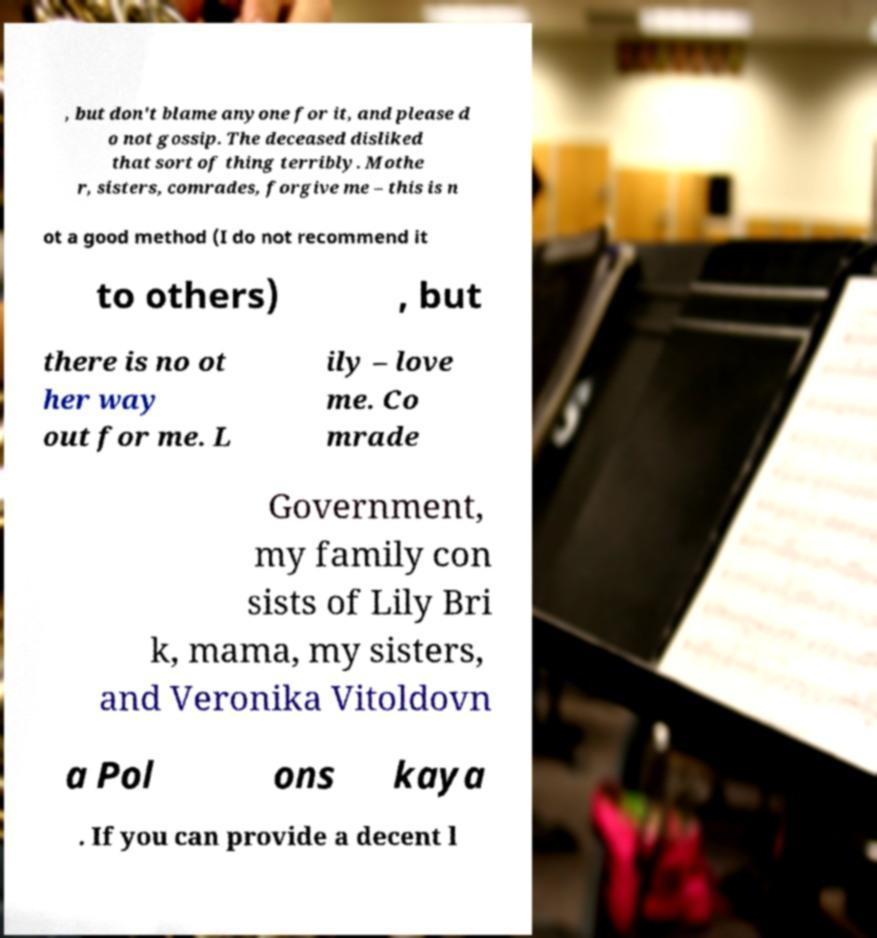Please identify and transcribe the text found in this image. , but don't blame anyone for it, and please d o not gossip. The deceased disliked that sort of thing terribly. Mothe r, sisters, comrades, forgive me – this is n ot a good method (I do not recommend it to others) , but there is no ot her way out for me. L ily – love me. Co mrade Government, my family con sists of Lily Bri k, mama, my sisters, and Veronika Vitoldovn a Pol ons kaya . If you can provide a decent l 